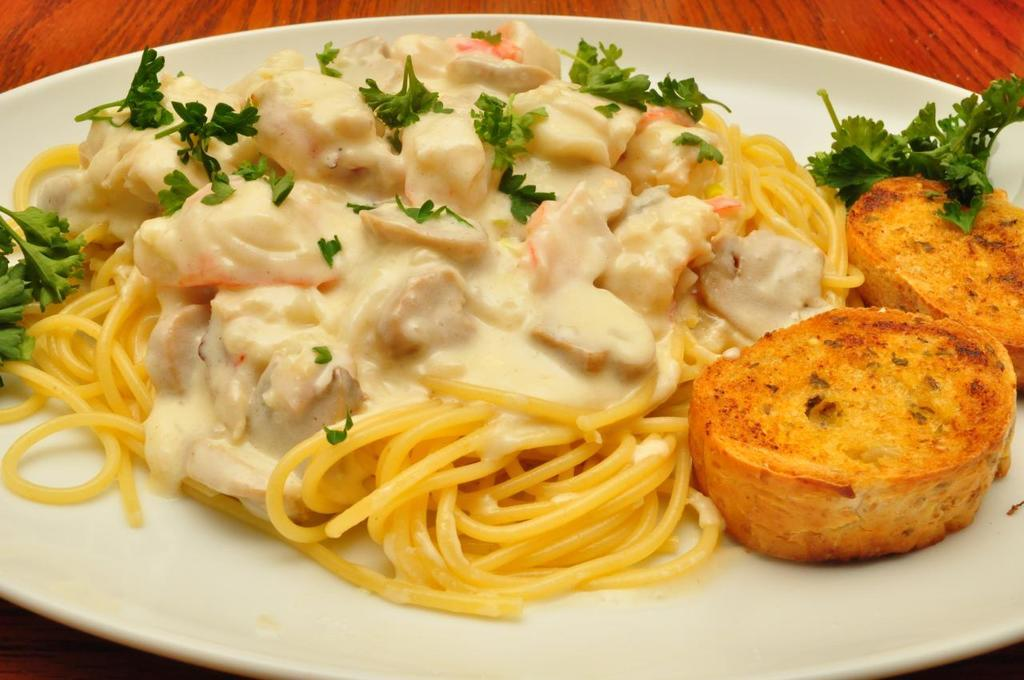What is on the wooden surface in the image? There is a plate on the wooden surface in the image. What is on the plate? There is a food item on the plate, which contains noodles and leaves. Are there any other ingredients in the food item? Yes, there are other items present in the food item. How does the crowd affect the temperature of the food item in the image? There is no crowd present in the image, so it cannot affect the temperature of the food item. 